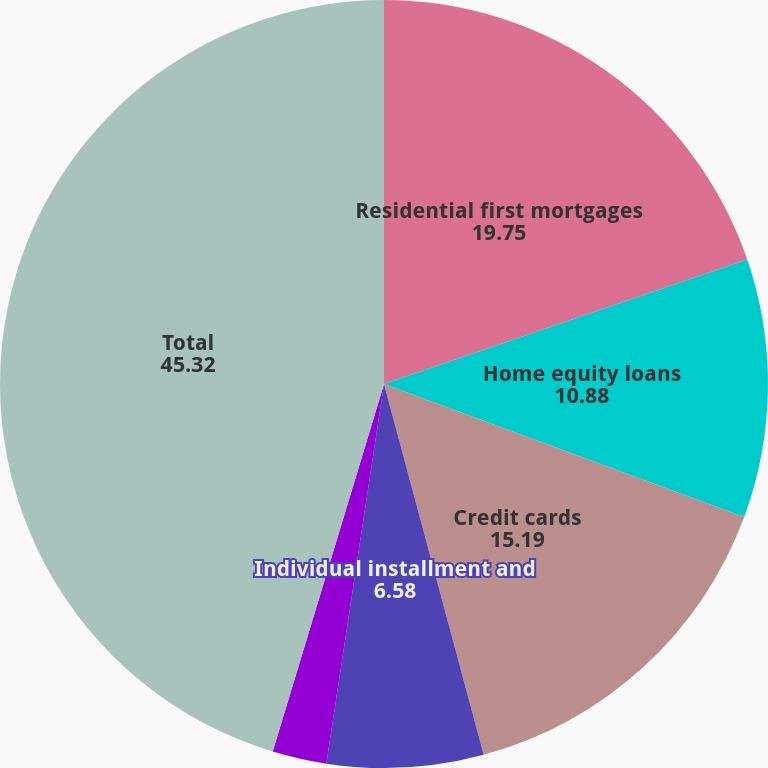Convert chart to OTSL. <chart><loc_0><loc_0><loc_500><loc_500><pie_chart><fcel>Residential first mortgages<fcel>Home equity loans<fcel>Credit cards<fcel>Individual installment and<fcel>Commercial banking<fcel>Total<nl><fcel>19.75%<fcel>10.88%<fcel>15.19%<fcel>6.58%<fcel>2.28%<fcel>45.32%<nl></chart> 